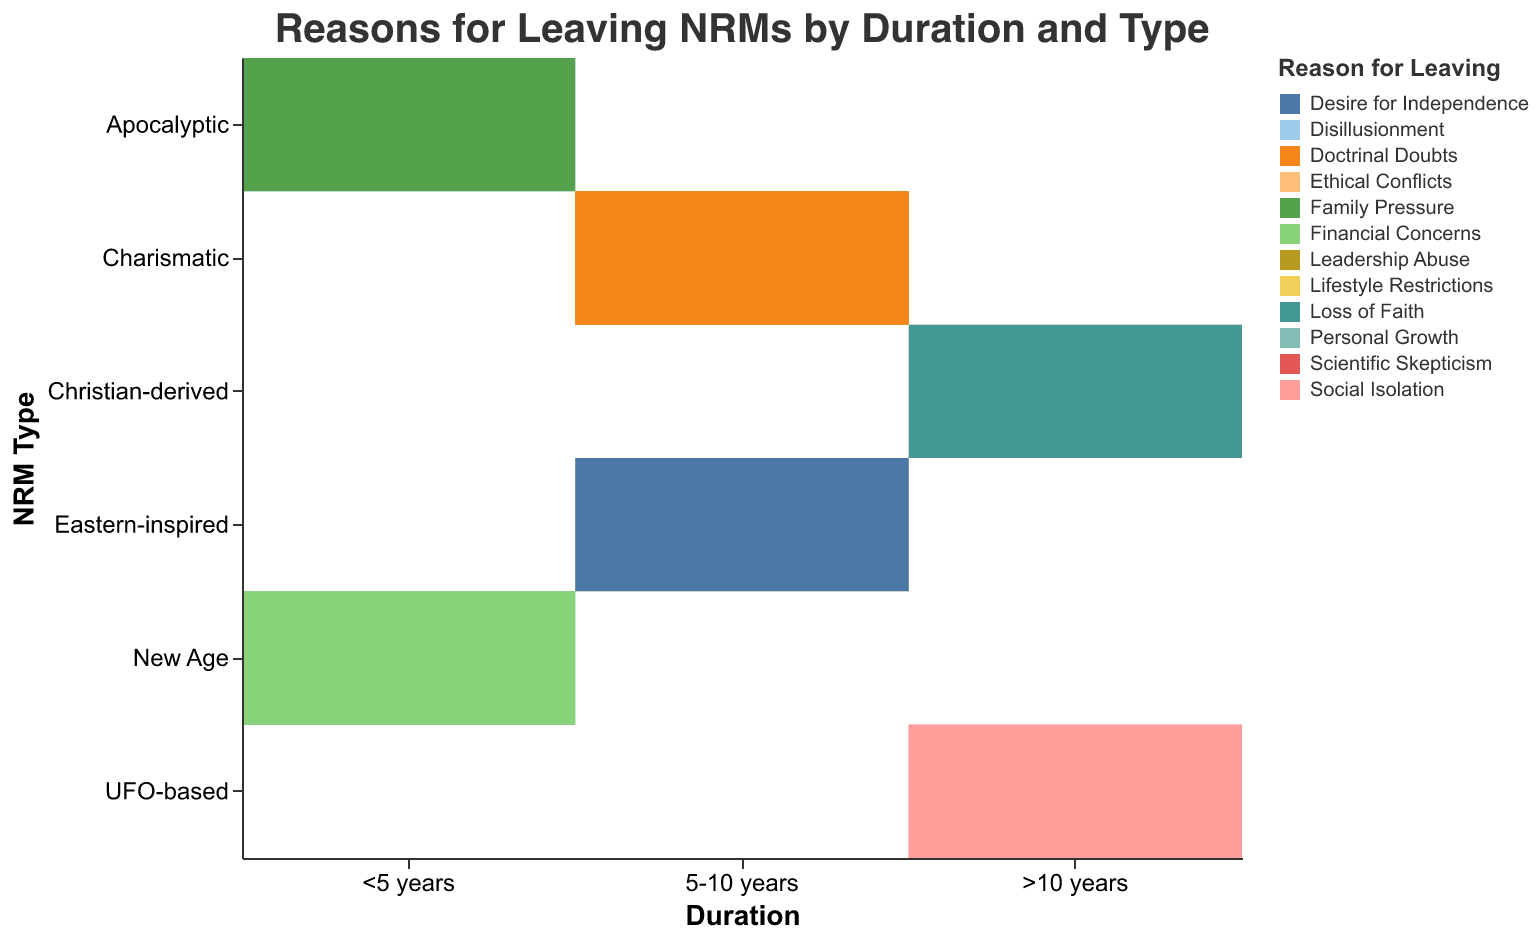What is the total count of people who left Apocalyptic NRMs within 5 years? To find the total count, sum up the counts for each reason for leaving Apocalyptic NRMs within 5 years: 15 (Disillusionment) + 8 (Family Pressure).
Answer: 23 What is the most common reason for leaving Christian-derived NRMs after more than 10 years? Compare the counts for each reason for leaving Christian-derived NRMs after more than 10 years: Ethical Conflicts (8) vs. Loss of Faith (6). Ethical Conflicts has the higher count.
Answer: Ethical Conflicts Which NRM Type had the highest count for the reason "Desire for Independence"? Identify the count for "Desire for Independence" within the NRM Types: Charismatic (11). Only one count is available, so Charismatic is the highest.
Answer: Eastern-inspired How does the count of people leaving due to Financial Concerns in New Age NRMs compare to those leaving due to Scientific Skepticism in UFO-based NRMs? Compare the counts: Financial Concerns in New Age NRMs (6) vs. Scientific Skepticism in UFO-based NRMs (5).
Answer: Financial Concerns (6) > Scientific Skepticism (5) Which duration category had the most varied reasons for leaving across all NRM types? Count the different reasons within each duration category:
- <5 years: 4 reasons
- 5-10 years: 4 reasons
- >10 years: 4 reasons
All categories have 4 reasons each, so they all have the same variety.
Answer: All categories have equal variety What are the combined counts for the reason "Leadership Abuse" and "Doctrinal Doubts" in Charismatic NRMs lasting 5-10 years? Sum the counts for "Leadership Abuse" and "Doctrinal Doubts" in Charismatic NRMs lasting 5-10 years: 10 (Leadership Abuse) + 7 (Doctrinal Doubts).
Answer: 17 What reason for leaving had the smallest count in the category ">10 years, UFO-based"? Compare the counts in the ">10 years, UFO-based" category: Scientific Skepticism (5) vs. Social Isolation (4). The smallest count is for Social Isolation.
Answer: Social Isolation Which NRM type and reason combination had the highest count? Look through all counts for each NRM type and reason combination to identify the highest: Apocalyptic (Disillusionment) with 15.
Answer: Apocalyptic (Disillusionment) 